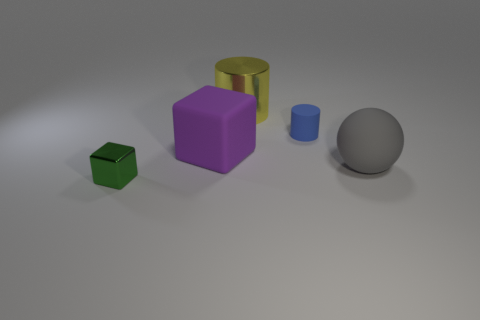Add 5 big objects. How many objects exist? 10 Subtract all spheres. How many objects are left? 4 Add 1 large balls. How many large balls exist? 2 Subtract 0 cyan cubes. How many objects are left? 5 Subtract all yellow shiny things. Subtract all small metal objects. How many objects are left? 3 Add 3 balls. How many balls are left? 4 